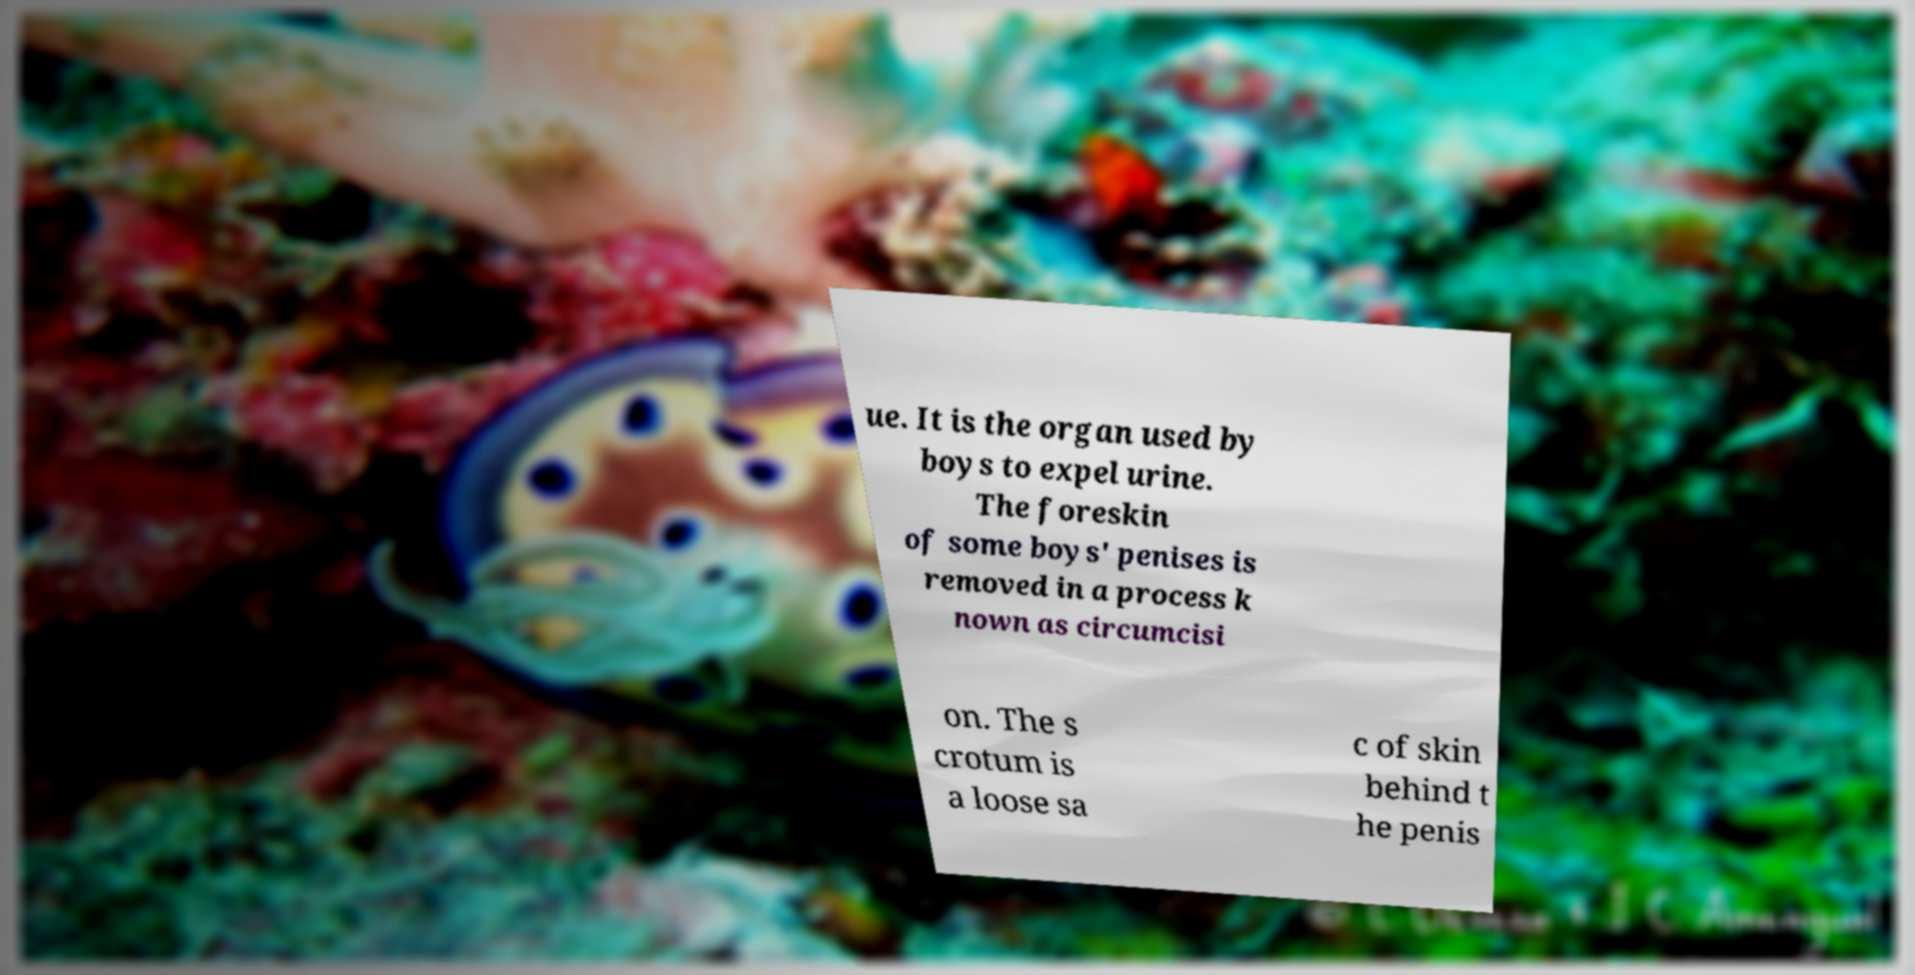For documentation purposes, I need the text within this image transcribed. Could you provide that? ue. It is the organ used by boys to expel urine. The foreskin of some boys' penises is removed in a process k nown as circumcisi on. The s crotum is a loose sa c of skin behind t he penis 